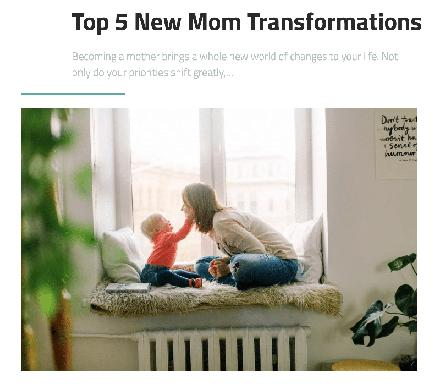What is the main topic of the text on the image? The text primarily discusses 'Top 5 New Mom Transformations,' highlighting the profound shifts in lifestyle, responsibilities, and emotional landscapes that a woman undergoes upon becoming a mother. It emphasizes the new insights and growth a mother experiences. 